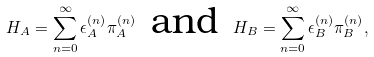Convert formula to latex. <formula><loc_0><loc_0><loc_500><loc_500>H _ { A } = \sum _ { n = 0 } ^ { \infty } \epsilon _ { A } ^ { ( n ) } \pi _ { A } ^ { ( n ) } \, \text { and } \, H _ { B } = \sum _ { n = 0 } ^ { \infty } \epsilon _ { B } ^ { ( n ) } \pi _ { B } ^ { ( n ) } ,</formula> 